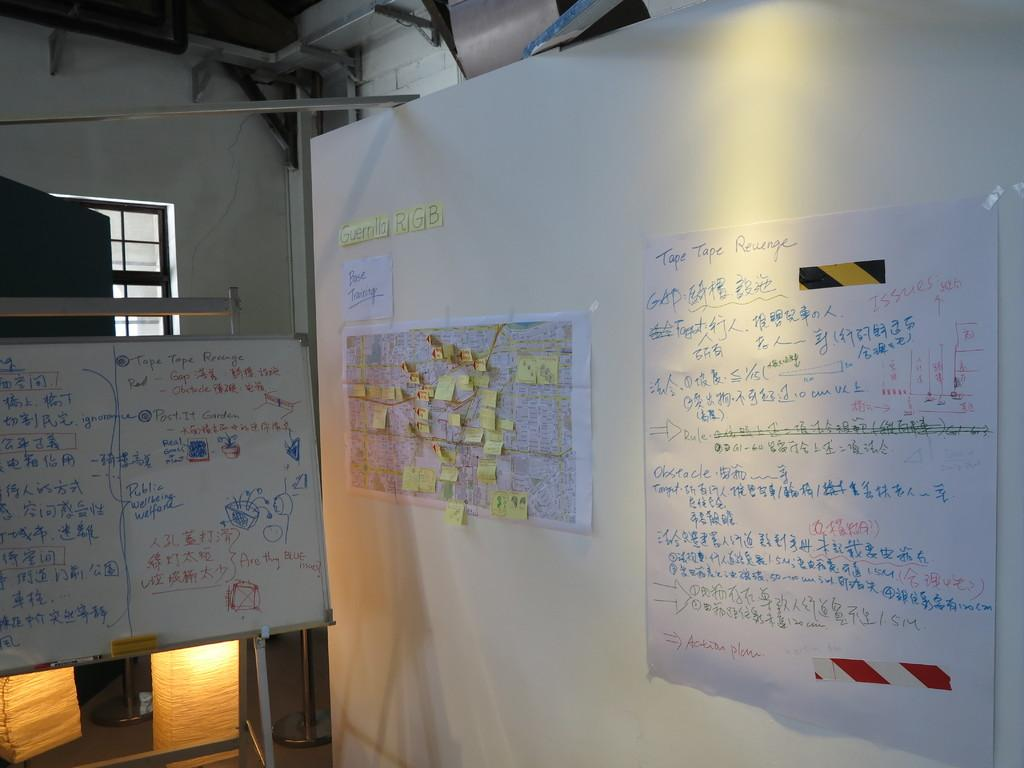<image>
Create a compact narrative representing the image presented. Two white boards covered with equasions and post it notes and information 